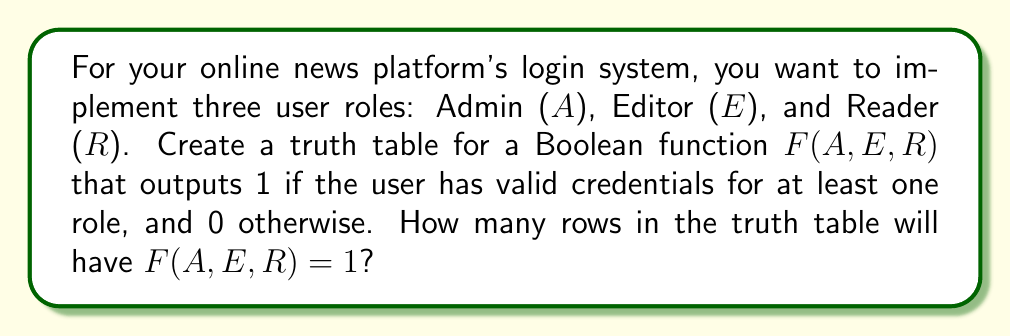Provide a solution to this math problem. Let's approach this step-by-step:

1) First, we need to understand what the variables represent:
   A: Admin access (1 if true, 0 if false)
   E: Editor access (1 if true, 0 if false)
   R: Reader access (1 if true, 0 if false)

2) The function $F(A,E,R)$ will output 1 if the user has valid credentials for at least one role. This can be represented as:

   $F(A,E,R) = A \lor E \lor R$

3) Now, let's create the truth table:

   | A | E | R | F(A,E,R) |
   |---|---|---|----------|
   | 0 | 0 | 0 |    0     |
   | 0 | 0 | 1 |    1     |
   | 0 | 1 | 0 |    1     |
   | 0 | 1 | 1 |    1     |
   | 1 | 0 | 0 |    1     |
   | 1 | 0 | 1 |    1     |
   | 1 | 1 | 0 |    1     |
   | 1 | 1 | 1 |    1     |

4) From the truth table, we can see that $F(A,E,R) = 1$ for all rows except the first one.

5) To count the number of rows where $F(A,E,R) = 1$, we can use the formula:

   Total rows - Rows where $F(A,E,R) = 0$

6) Total rows = $2^3 = 8$ (since we have 3 variables)
   Rows where $F(A,E,R) = 0$ = 1

7) Therefore, the number of rows where $F(A,E,R) = 1$ is:
   $8 - 1 = 7$
Answer: 7 